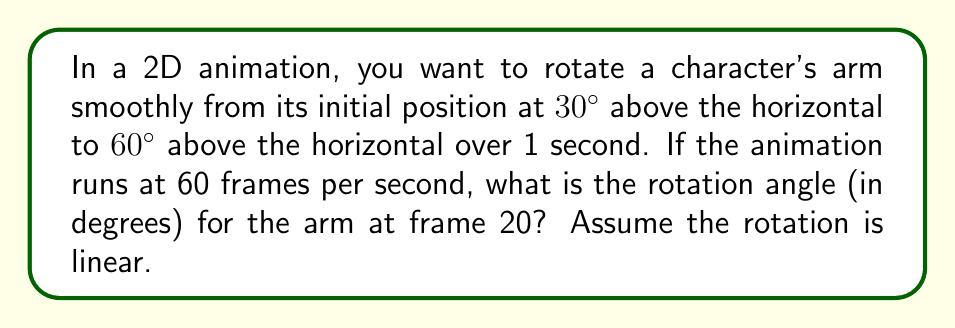Give your solution to this math problem. Let's approach this step-by-step:

1) First, we need to calculate the total rotation:
   $$\text{Total rotation} = 60° - 30° = 30°$$

2) Now, we need to determine how many frames the entire animation will take:
   $$\text{Total frames} = 1 \text{ second} \times 60 \text{ frames/second} = 60 \text{ frames}$$

3) We can calculate the rotation per frame:
   $$\text{Rotation per frame} = \frac{\text{Total rotation}}{\text{Total frames}} = \frac{30°}{60} = 0.5° \text{ per frame}$$

4) At frame 20, the additional rotation will be:
   $$\text{Additional rotation} = 20 \text{ frames} \times 0.5° \text{ per frame} = 10°$$

5) Therefore, the final angle at frame 20 will be:
   $$\text{Final angle} = \text{Initial angle} + \text{Additional rotation}$$
   $$\text{Final angle} = 30° + 10° = 40°$$

This linear interpolation between angles is a fundamental technique in computer animation, often implemented using trigonometric functions in the actual rendering process.
Answer: $40°$ 